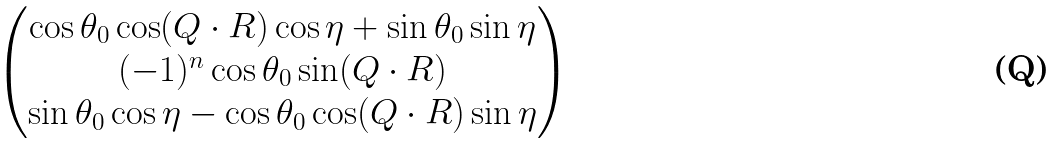Convert formula to latex. <formula><loc_0><loc_0><loc_500><loc_500>\begin{pmatrix} \cos \theta _ { 0 } \cos ( { Q } \cdot { R } ) \cos \eta + \sin \theta _ { 0 } \sin \eta \\ ( - 1 ) ^ { n } \cos \theta _ { 0 } \sin ( { Q } \cdot { R } ) \\ \sin \theta _ { 0 } \cos \eta - \cos \theta _ { 0 } \cos ( { Q } \cdot { R } ) \sin \eta \end{pmatrix}</formula> 